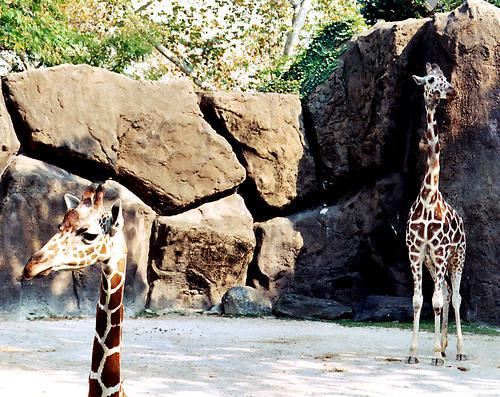Question: how many giraffes are pictured in full body?
Choices:
A. 2.
B. 1.
C. 3.
D. 4.
Answer with the letter. Answer: B Question: what is behind the giraffes?
Choices:
A. Mountains.
B. A cheetah.
C. Boulders and trees.
D. A lake.
Answer with the letter. Answer: C Question: how many giraffes are there?
Choices:
A. 3.
B. 4.
C. 2.
D. 5.
Answer with the letter. Answer: C Question: what color are the rocks?
Choices:
A. Black.
B. Brown.
C. White.
D. Grey.
Answer with the letter. Answer: B 